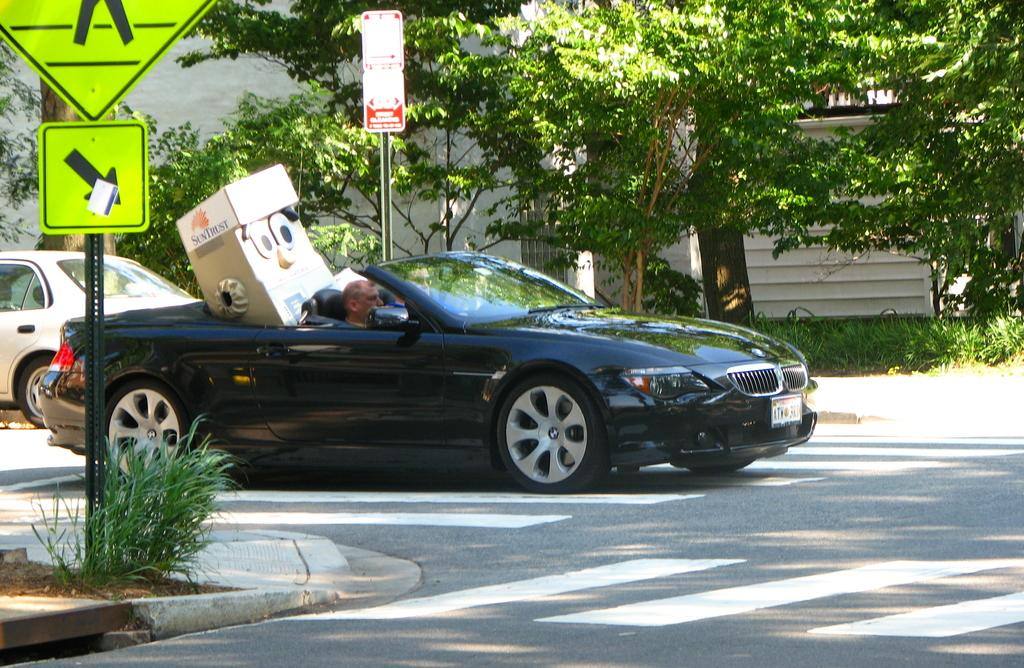How many cars can be seen in the image? There are 2 cars in the image. Where are the cars located? The cars are on the road. What else can be seen in the image besides the cars? There are 2 sign boards, plants, and trees visible in the image. Is the queen sitting on a quill in the image? There is no queen or quill present in the image. 